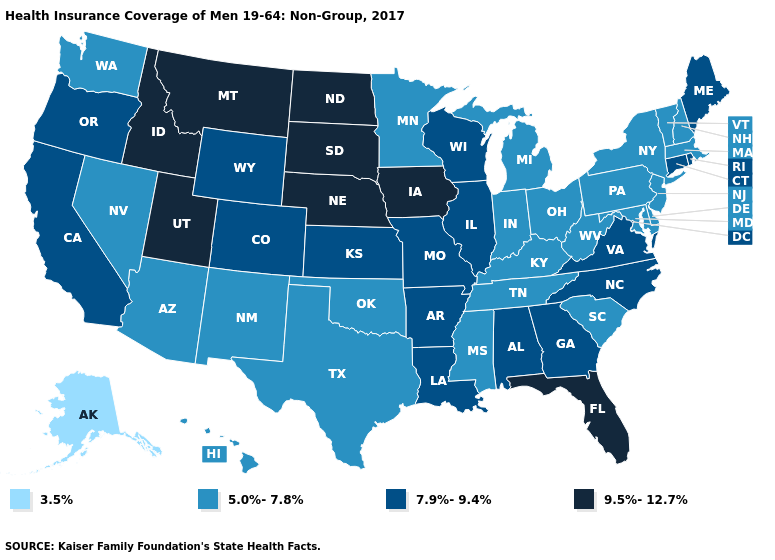Which states have the highest value in the USA?
Be succinct. Florida, Idaho, Iowa, Montana, Nebraska, North Dakota, South Dakota, Utah. Does Tennessee have the highest value in the USA?
Answer briefly. No. Does the map have missing data?
Give a very brief answer. No. Does Connecticut have the lowest value in the Northeast?
Be succinct. No. What is the lowest value in states that border Arizona?
Write a very short answer. 5.0%-7.8%. What is the highest value in the Northeast ?
Quick response, please. 7.9%-9.4%. Name the states that have a value in the range 7.9%-9.4%?
Quick response, please. Alabama, Arkansas, California, Colorado, Connecticut, Georgia, Illinois, Kansas, Louisiana, Maine, Missouri, North Carolina, Oregon, Rhode Island, Virginia, Wisconsin, Wyoming. Name the states that have a value in the range 9.5%-12.7%?
Short answer required. Florida, Idaho, Iowa, Montana, Nebraska, North Dakota, South Dakota, Utah. What is the value of New York?
Give a very brief answer. 5.0%-7.8%. Name the states that have a value in the range 7.9%-9.4%?
Concise answer only. Alabama, Arkansas, California, Colorado, Connecticut, Georgia, Illinois, Kansas, Louisiana, Maine, Missouri, North Carolina, Oregon, Rhode Island, Virginia, Wisconsin, Wyoming. Does the map have missing data?
Quick response, please. No. What is the highest value in the USA?
Answer briefly. 9.5%-12.7%. Does the map have missing data?
Short answer required. No. Does Arizona have a higher value than California?
Quick response, please. No. Is the legend a continuous bar?
Short answer required. No. 